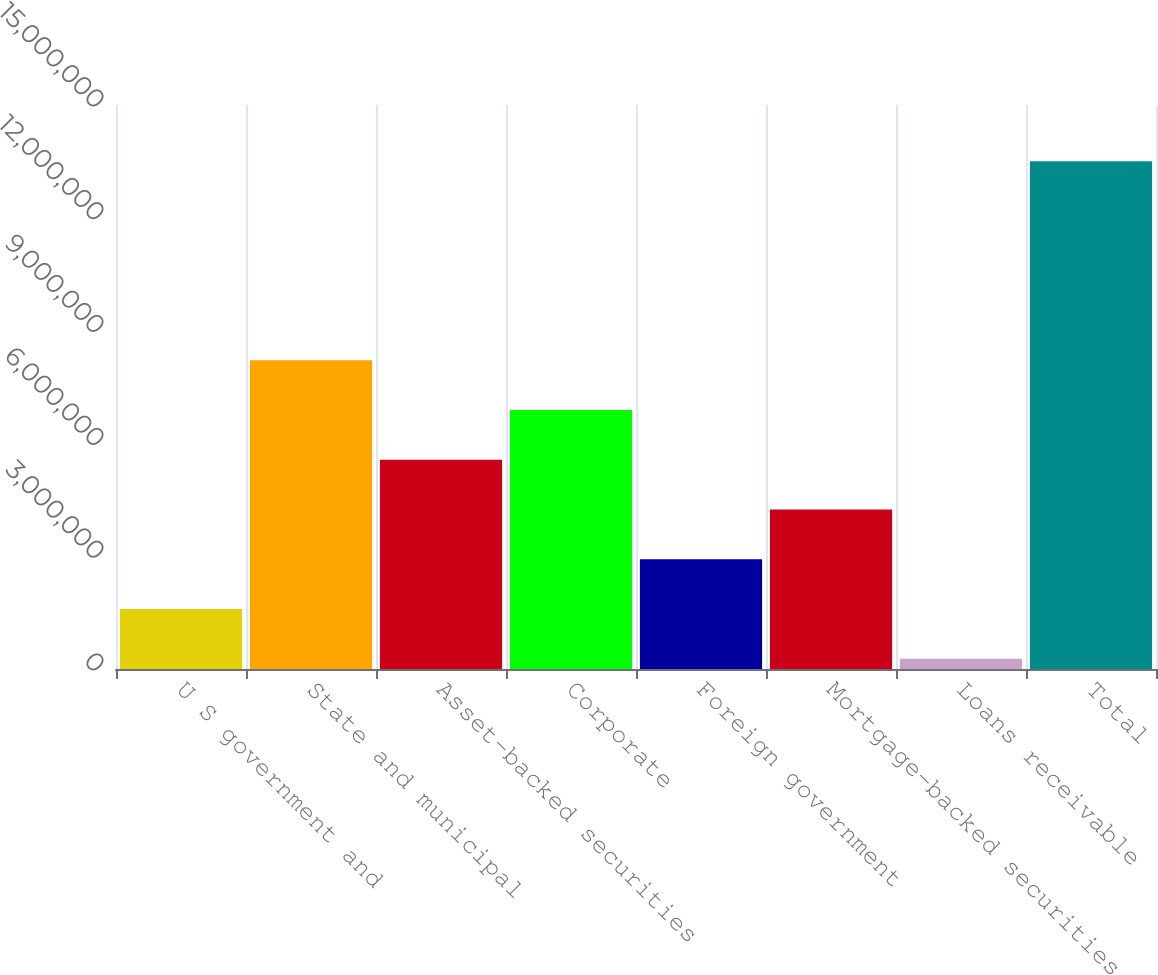Convert chart. <chart><loc_0><loc_0><loc_500><loc_500><bar_chart><fcel>U S government and<fcel>State and municipal<fcel>Asset-backed securities<fcel>Corporate<fcel>Foreign government<fcel>Mortgage-backed securities<fcel>Loans receivable<fcel>Total<nl><fcel>1.59839e+06<fcel>8.21163e+06<fcel>5.56634e+06<fcel>6.88899e+06<fcel>2.92104e+06<fcel>4.24369e+06<fcel>275747<fcel>1.35022e+07<nl></chart> 